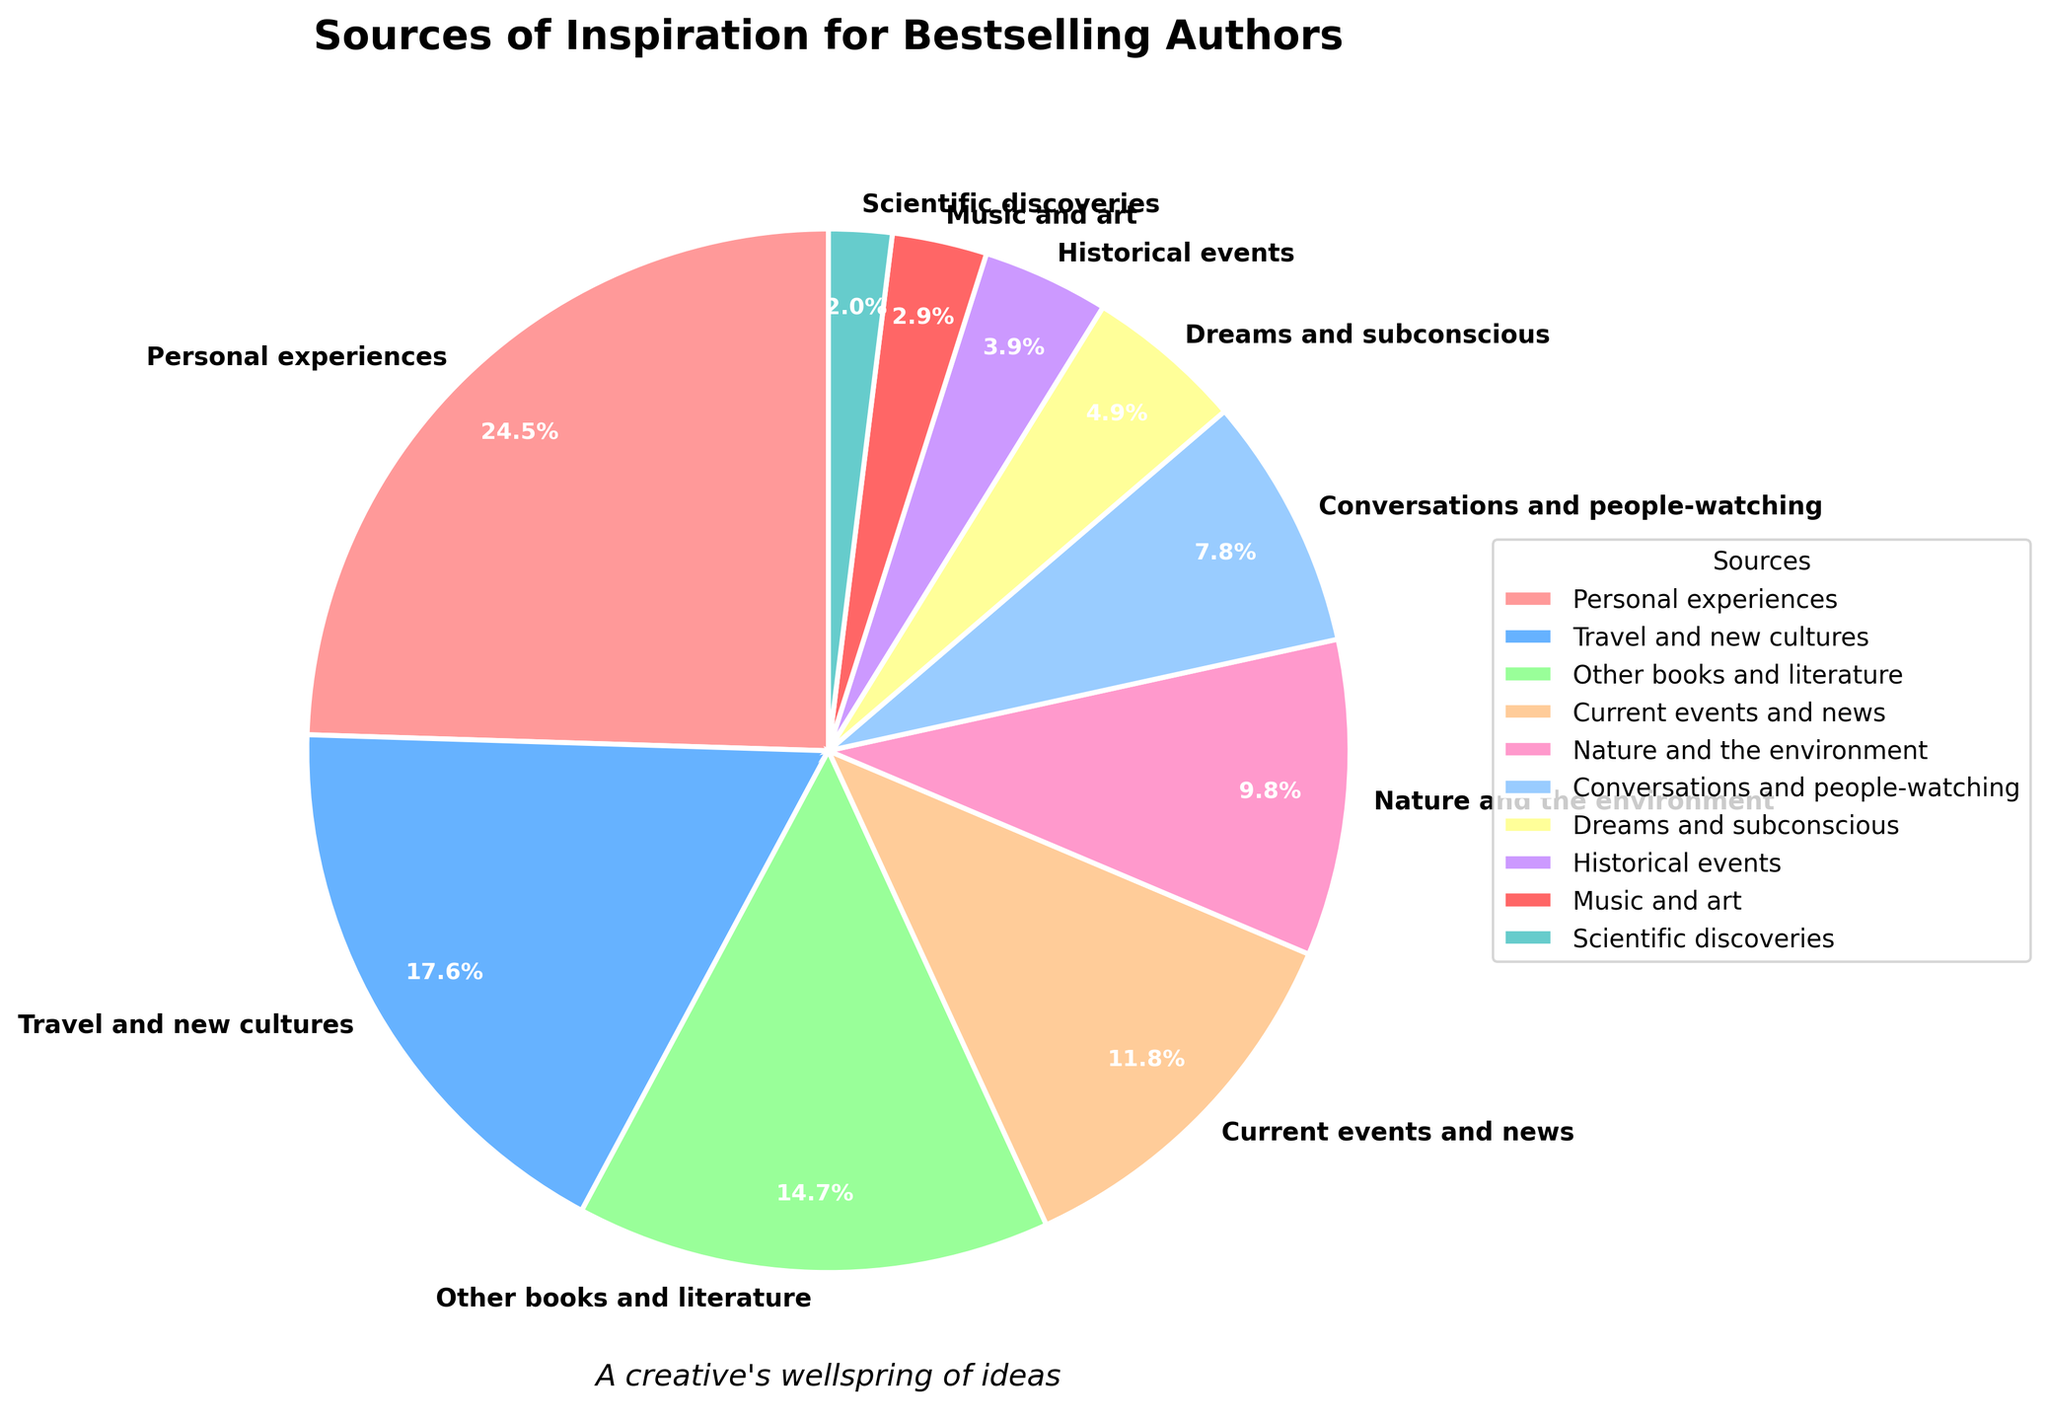What's the largest source of inspiration for bestselling authors? The largest percentage of the pie chart represents the largest source of inspiration. The slice labeled "Personal experiences" has the biggest size.
Answer: Personal experiences Which source of inspiration is represented by the smallest slice of the pie chart? The smallest slice has the label "Scientific discoveries" with the smallest percentage.
Answer: Scientific discoveries What is the combined percentage of "Travel and new cultures" and "Nature and the environment"? Sum the percentages of "Travel and new cultures" (18%) and "Nature and the environment" (10%): 18% + 10% = 28%
Answer: 28% Is the inspiration from "Conversations and people-watching" greater than from "Historical events"? Compare the percentages: "Conversations and people-watching" has 8%, while "Historical events" has 4%. 8% is greater than 4%.
Answer: Yes What's the difference between the sources of inspiration from "Other books and literature" and "Music and art"? Subtract the percentage of "Music and art" (3%) from "Other books and literature" (15%): 15% - 3% = 12%
Answer: 12% Which categories together account for exactly half of the inspiration sources? Look for categories summing up to 50%. "Personal experiences" (25%) and "Travel and new cultures" (18%) add up to 43%, adding "Other books and literature" (15%) makes it 58%, too much. However, "Personal experiences" (25%), "Travel and new cultures" (18%), and "Current events and news" (12%) together make 55%, too much again. The combination "Travel and new cultures" (18%), "Other books and literature" (15%), "Current events and news" (12%), and "Nature and the environment" (10%) makes 55%. This solution doesn't exist.
Answer: N/A What are the top three sources of inspiration in terms of percentage? Identify the three largest percentages: "Personal experiences" (25%), "Travel and new cultures" (18%), and "Other books and literature" (15%).
Answer: Personal experiences, Travel and new cultures, Other books and literature What is the percentage difference between "Dreams and subconscious" and "Music and art"? Subtract the percentage of "Music and art" (3%) from "Dreams and subconscious" (5%): 5% - 3% = 2%
Answer: 2% Between “Current events and news” and “Dreams and subconscious,” which one has a larger share? Compare their percentages: "Current events and news" has 12%, while "Dreams and subconscious" has 5%.
Answer: Current events and news What is the combined share of all sources of inspiration that have less than 10% each? Sum the percentages of all categories below 10%: "Conversations and people-watching" (8%), "Dreams and subconscious" (5%), "Historical events" (4%), "Music and art" (3%), and "Scientific discoveries" (2%): 8% + 5% + 4% + 3% + 2% = 22%
Answer: 22% 